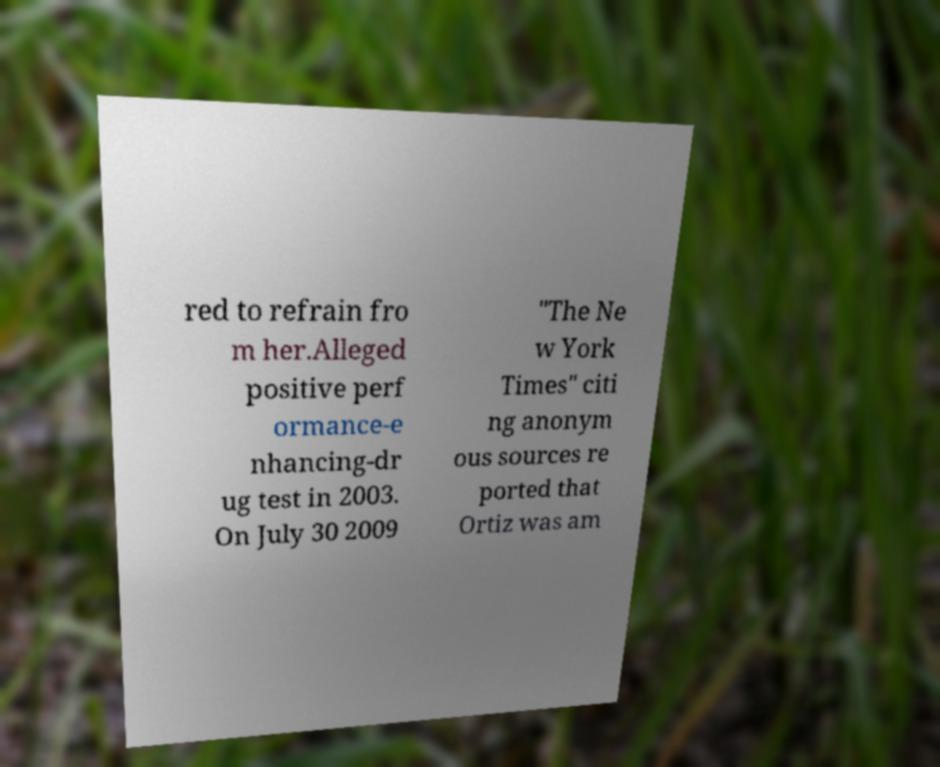Could you assist in decoding the text presented in this image and type it out clearly? red to refrain fro m her.Alleged positive perf ormance-e nhancing-dr ug test in 2003. On July 30 2009 "The Ne w York Times" citi ng anonym ous sources re ported that Ortiz was am 